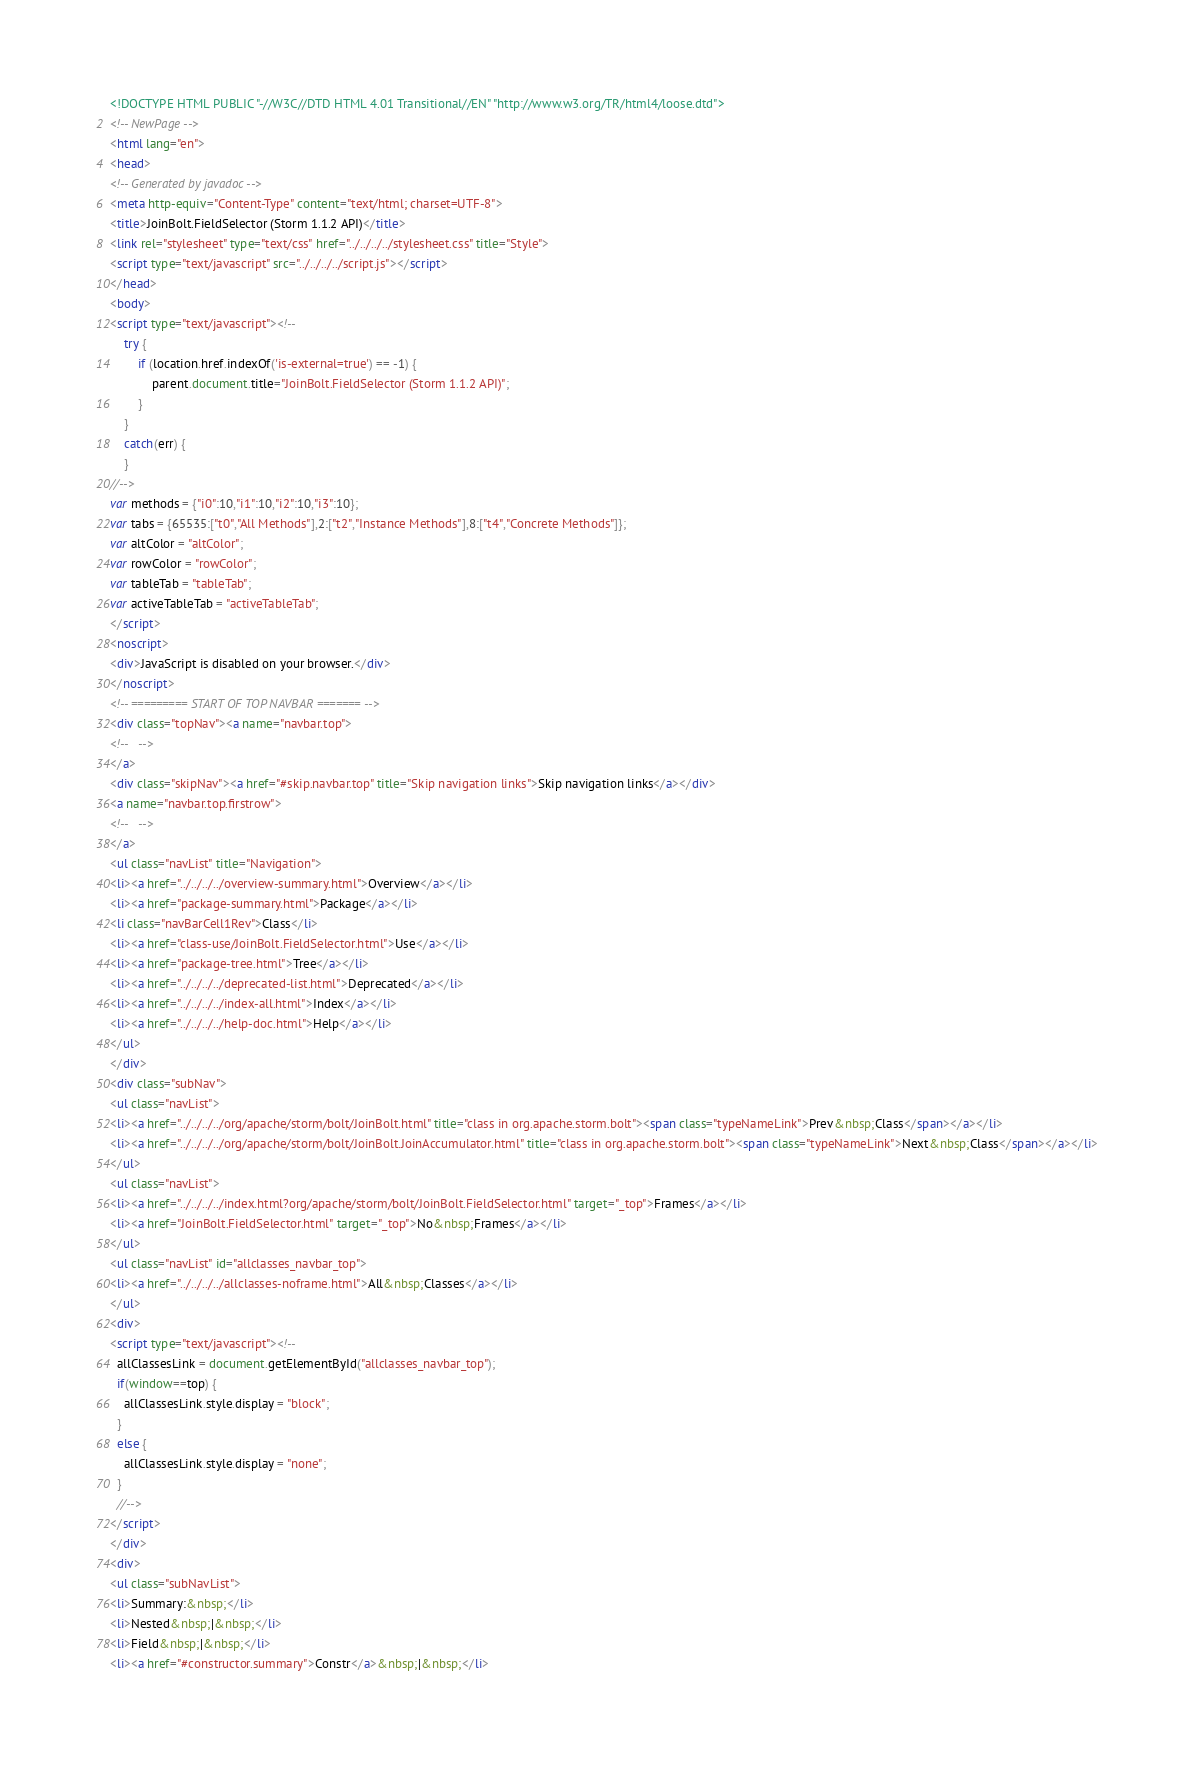Convert code to text. <code><loc_0><loc_0><loc_500><loc_500><_HTML_><!DOCTYPE HTML PUBLIC "-//W3C//DTD HTML 4.01 Transitional//EN" "http://www.w3.org/TR/html4/loose.dtd">
<!-- NewPage -->
<html lang="en">
<head>
<!-- Generated by javadoc -->
<meta http-equiv="Content-Type" content="text/html; charset=UTF-8">
<title>JoinBolt.FieldSelector (Storm 1.1.2 API)</title>
<link rel="stylesheet" type="text/css" href="../../../../stylesheet.css" title="Style">
<script type="text/javascript" src="../../../../script.js"></script>
</head>
<body>
<script type="text/javascript"><!--
    try {
        if (location.href.indexOf('is-external=true') == -1) {
            parent.document.title="JoinBolt.FieldSelector (Storm 1.1.2 API)";
        }
    }
    catch(err) {
    }
//-->
var methods = {"i0":10,"i1":10,"i2":10,"i3":10};
var tabs = {65535:["t0","All Methods"],2:["t2","Instance Methods"],8:["t4","Concrete Methods"]};
var altColor = "altColor";
var rowColor = "rowColor";
var tableTab = "tableTab";
var activeTableTab = "activeTableTab";
</script>
<noscript>
<div>JavaScript is disabled on your browser.</div>
</noscript>
<!-- ========= START OF TOP NAVBAR ======= -->
<div class="topNav"><a name="navbar.top">
<!--   -->
</a>
<div class="skipNav"><a href="#skip.navbar.top" title="Skip navigation links">Skip navigation links</a></div>
<a name="navbar.top.firstrow">
<!--   -->
</a>
<ul class="navList" title="Navigation">
<li><a href="../../../../overview-summary.html">Overview</a></li>
<li><a href="package-summary.html">Package</a></li>
<li class="navBarCell1Rev">Class</li>
<li><a href="class-use/JoinBolt.FieldSelector.html">Use</a></li>
<li><a href="package-tree.html">Tree</a></li>
<li><a href="../../../../deprecated-list.html">Deprecated</a></li>
<li><a href="../../../../index-all.html">Index</a></li>
<li><a href="../../../../help-doc.html">Help</a></li>
</ul>
</div>
<div class="subNav">
<ul class="navList">
<li><a href="../../../../org/apache/storm/bolt/JoinBolt.html" title="class in org.apache.storm.bolt"><span class="typeNameLink">Prev&nbsp;Class</span></a></li>
<li><a href="../../../../org/apache/storm/bolt/JoinBolt.JoinAccumulator.html" title="class in org.apache.storm.bolt"><span class="typeNameLink">Next&nbsp;Class</span></a></li>
</ul>
<ul class="navList">
<li><a href="../../../../index.html?org/apache/storm/bolt/JoinBolt.FieldSelector.html" target="_top">Frames</a></li>
<li><a href="JoinBolt.FieldSelector.html" target="_top">No&nbsp;Frames</a></li>
</ul>
<ul class="navList" id="allclasses_navbar_top">
<li><a href="../../../../allclasses-noframe.html">All&nbsp;Classes</a></li>
</ul>
<div>
<script type="text/javascript"><!--
  allClassesLink = document.getElementById("allclasses_navbar_top");
  if(window==top) {
    allClassesLink.style.display = "block";
  }
  else {
    allClassesLink.style.display = "none";
  }
  //-->
</script>
</div>
<div>
<ul class="subNavList">
<li>Summary:&nbsp;</li>
<li>Nested&nbsp;|&nbsp;</li>
<li>Field&nbsp;|&nbsp;</li>
<li><a href="#constructor.summary">Constr</a>&nbsp;|&nbsp;</li></code> 